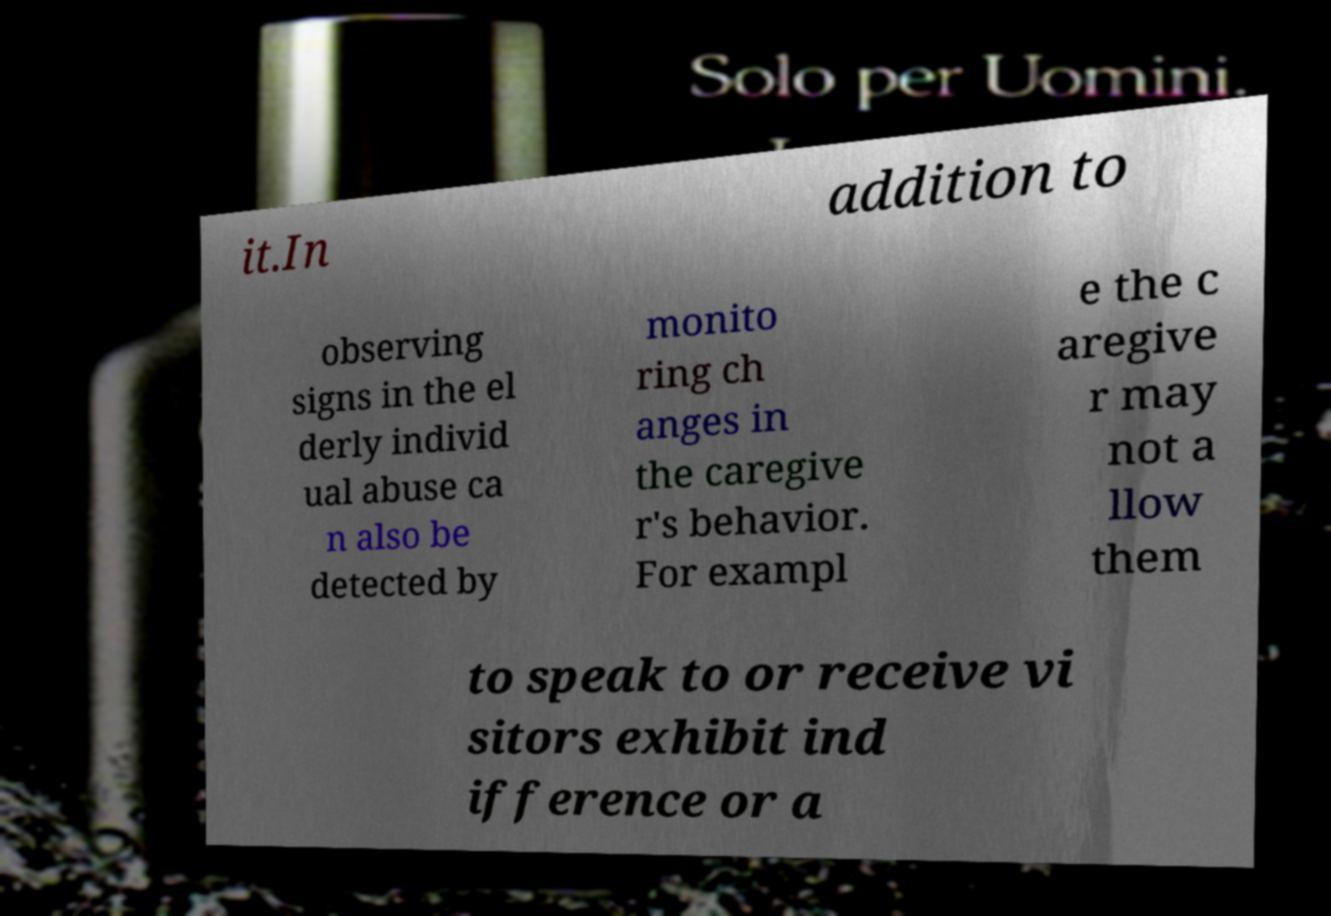Please identify and transcribe the text found in this image. it.In addition to observing signs in the el derly individ ual abuse ca n also be detected by monito ring ch anges in the caregive r's behavior. For exampl e the c aregive r may not a llow them to speak to or receive vi sitors exhibit ind ifference or a 